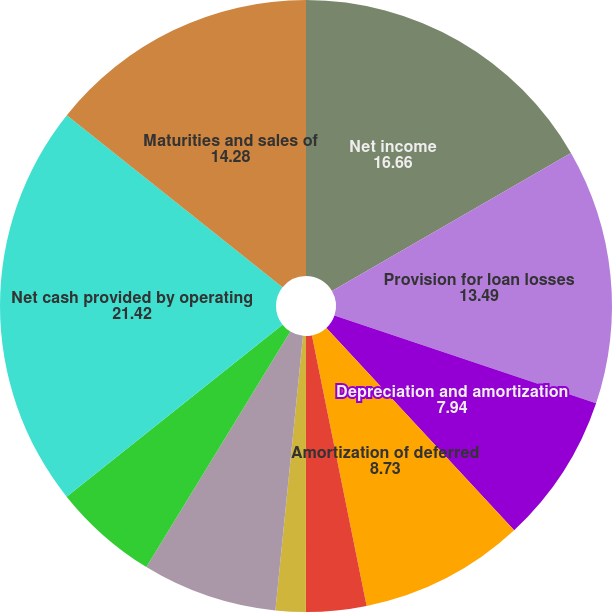Convert chart. <chart><loc_0><loc_0><loc_500><loc_500><pie_chart><fcel>Net income<fcel>Provision for loan losses<fcel>Depreciation and amortization<fcel>Amortization of deferred<fcel>Net loss (gain) on investments<fcel>Other net<fcel>Increase in other assets<fcel>Increase in accrued expenses<fcel>Net cash provided by operating<fcel>Maturities and sales of<nl><fcel>16.66%<fcel>13.49%<fcel>7.94%<fcel>8.73%<fcel>3.18%<fcel>1.59%<fcel>7.14%<fcel>5.56%<fcel>21.42%<fcel>14.28%<nl></chart> 